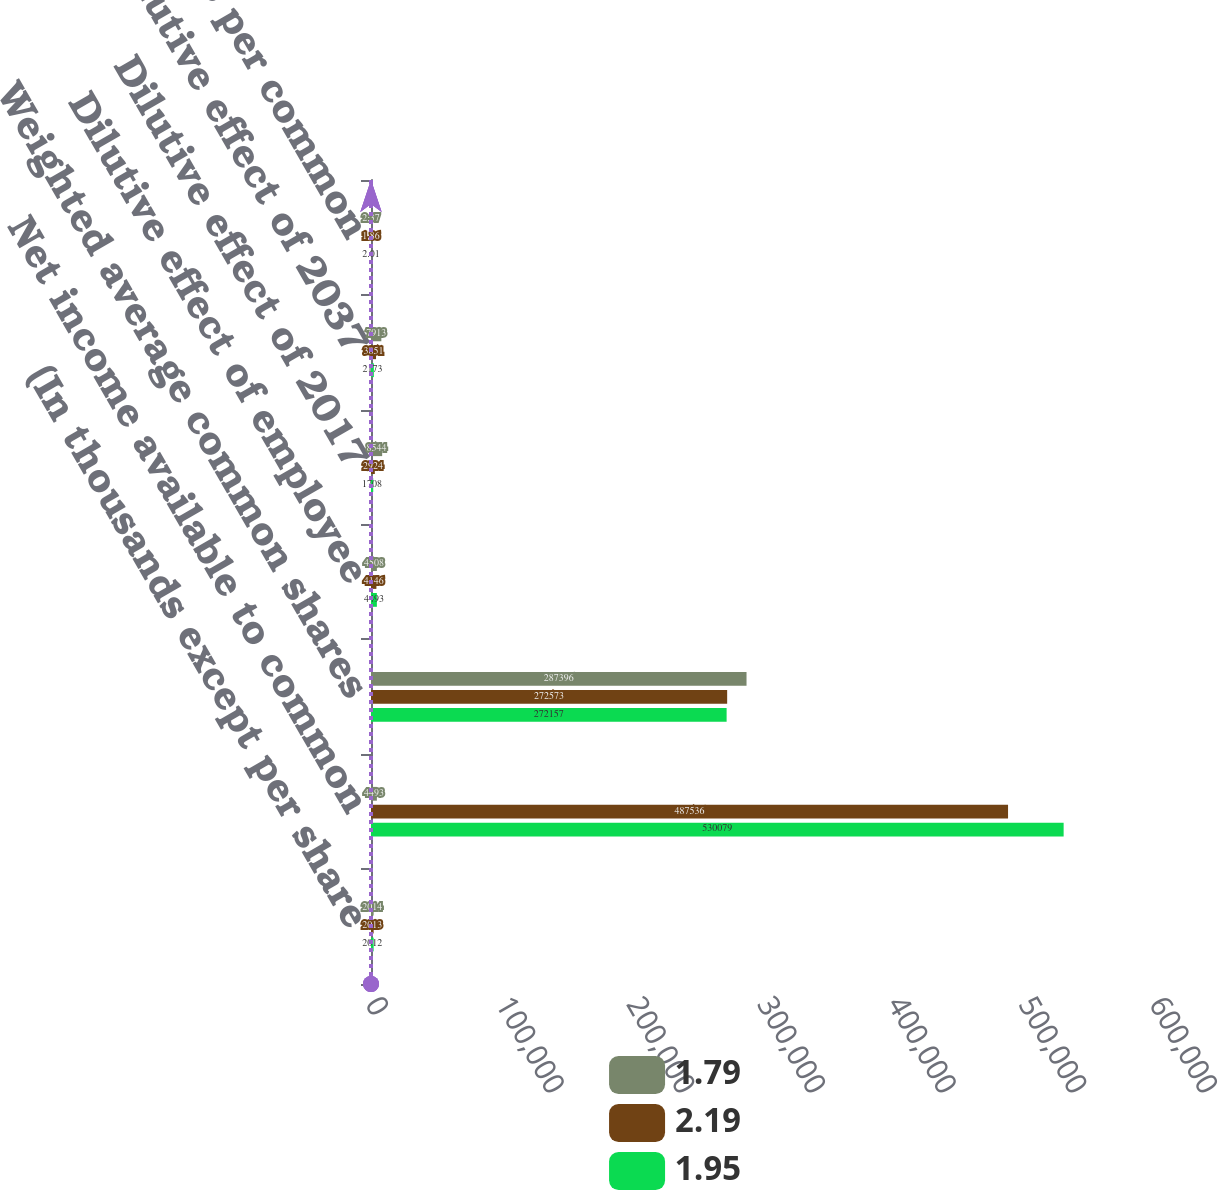Convert chart. <chart><loc_0><loc_0><loc_500><loc_500><stacked_bar_chart><ecel><fcel>(In thousands except per share<fcel>Net income available to common<fcel>Weighted average common shares<fcel>Dilutive effect of employee<fcel>Dilutive effect of 2017<fcel>Dilutive effect of 2037<fcel>Basic earnings per common<nl><fcel>1.79<fcel>2014<fcel>4493<fcel>287396<fcel>4508<fcel>8544<fcel>7913<fcel>2.37<nl><fcel>2.19<fcel>2013<fcel>487536<fcel>272573<fcel>4146<fcel>2924<fcel>3851<fcel>1.86<nl><fcel>1.95<fcel>2012<fcel>530079<fcel>272157<fcel>4493<fcel>1708<fcel>2173<fcel>2.01<nl></chart> 